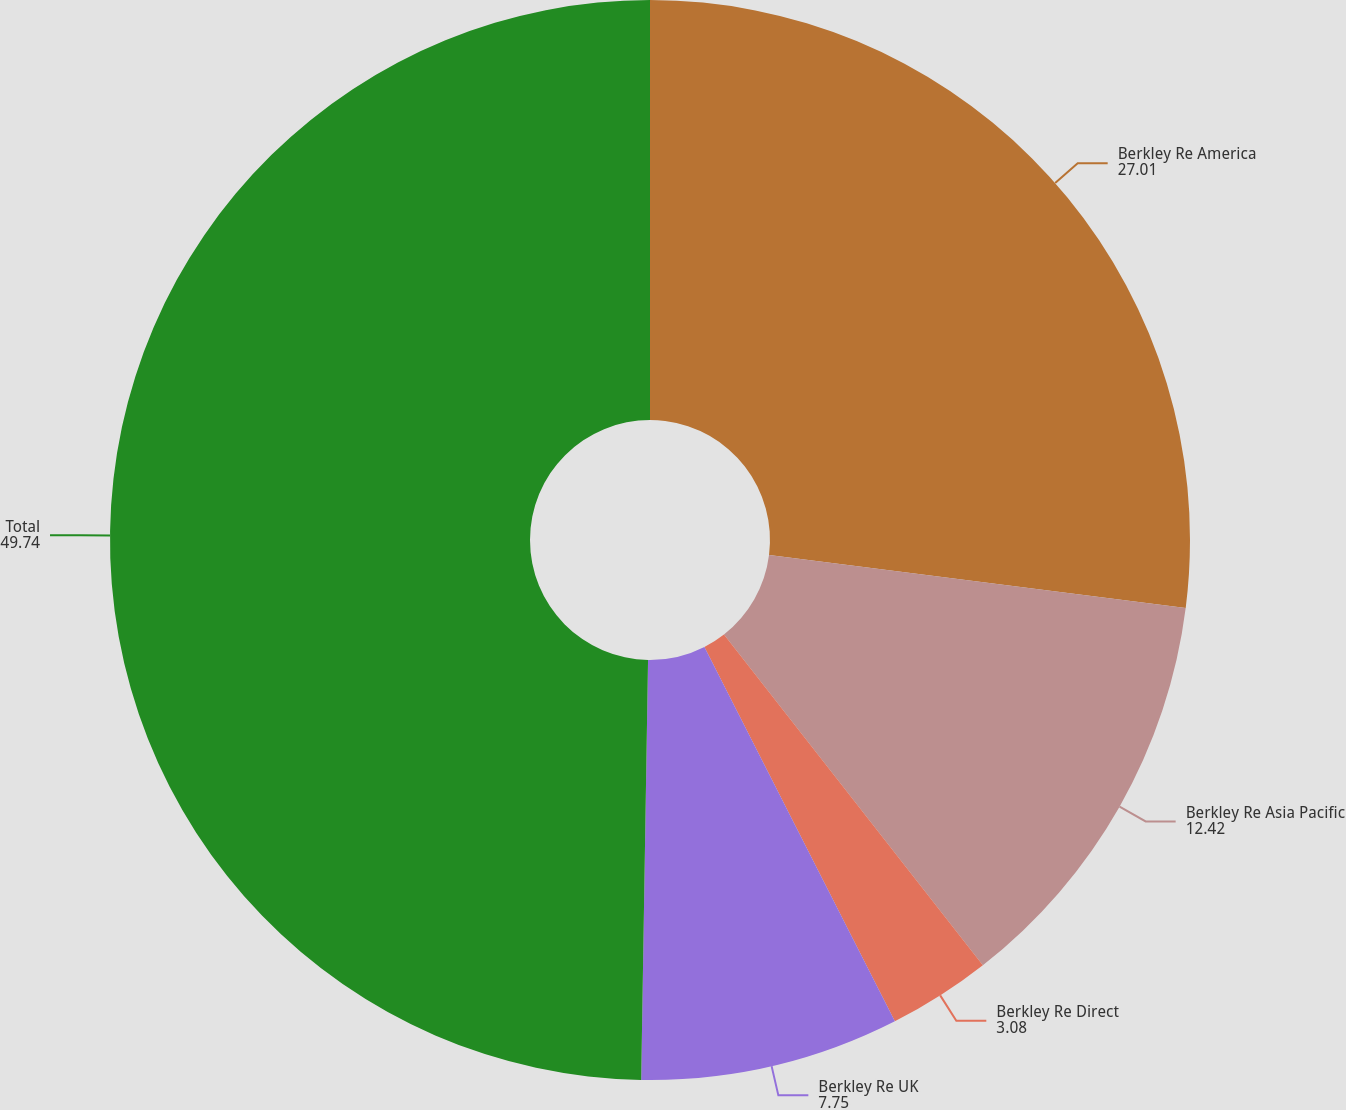<chart> <loc_0><loc_0><loc_500><loc_500><pie_chart><fcel>Berkley Re America<fcel>Berkley Re Asia Pacific<fcel>Berkley Re Direct<fcel>Berkley Re UK<fcel>Total<nl><fcel>27.01%<fcel>12.42%<fcel>3.08%<fcel>7.75%<fcel>49.74%<nl></chart> 